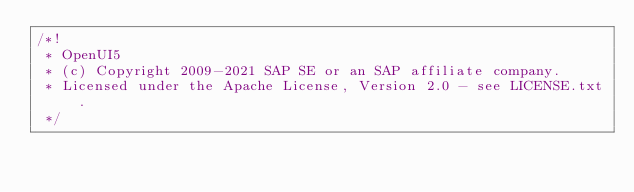Convert code to text. <code><loc_0><loc_0><loc_500><loc_500><_JavaScript_>/*!
 * OpenUI5
 * (c) Copyright 2009-2021 SAP SE or an SAP affiliate company.
 * Licensed under the Apache License, Version 2.0 - see LICENSE.txt.
 */</code> 